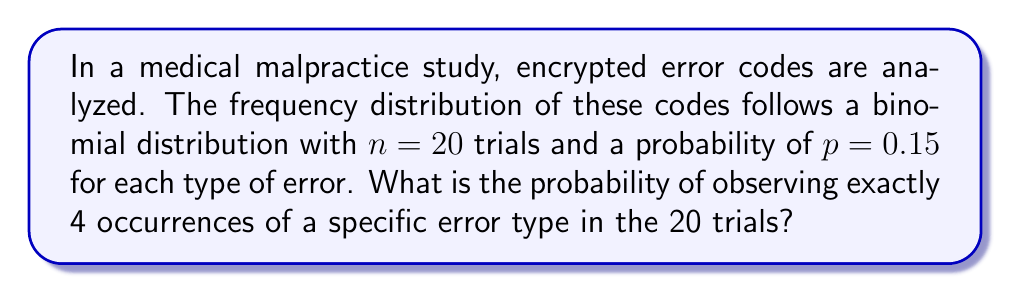What is the answer to this math problem? To solve this problem, we'll use the binomial probability formula:

$$P(X = k) = \binom{n}{k} p^k (1-p)^{n-k}$$

Where:
- $n$ is the number of trials (20)
- $k$ is the number of successes (4)
- $p$ is the probability of success on each trial (0.15)

Step 1: Calculate the binomial coefficient $\binom{n}{k}$
$$\binom{20}{4} = \frac{20!}{4!(20-4)!} = \frac{20!}{4!16!} = 4845$$

Step 2: Calculate $p^k$
$$0.15^4 = 0.0005062500$$

Step 3: Calculate $(1-p)^{n-k}$
$$(1-0.15)^{20-4} = 0.85^{16} = 0.0437211253$$

Step 4: Multiply the results from steps 1, 2, and 3
$$4845 \times 0.0005062500 \times 0.0437211253 = 0.1069644730$$

Therefore, the probability of observing exactly 4 occurrences of a specific error type in 20 trials is approximately 0.1070 or 10.70%.
Answer: 0.1070 